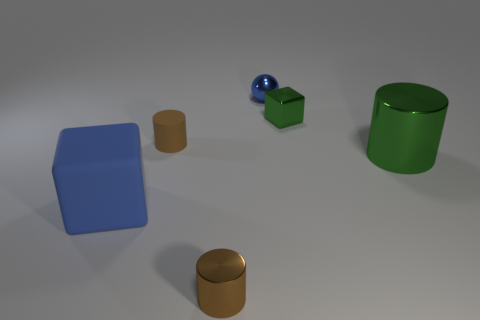There is a tiny metallic cylinder; is it the same color as the matte object to the right of the big blue matte object?
Your answer should be very brief. Yes. The metal thing that is the same color as the small rubber thing is what shape?
Give a very brief answer. Cylinder. There is a tiny matte thing; what shape is it?
Give a very brief answer. Cylinder. Do the large rubber thing and the metal ball have the same color?
Provide a short and direct response. Yes. How many objects are either cylinders to the left of the tiny blue object or small green things?
Give a very brief answer. 3. The brown cylinder that is made of the same material as the large green cylinder is what size?
Offer a very short reply. Small. Is the number of shiny blocks in front of the tiny green shiny block greater than the number of big gray cylinders?
Your answer should be very brief. No. Do the small green thing and the small object behind the tiny cube have the same shape?
Your response must be concise. No. How many small objects are matte cylinders or green cylinders?
Provide a short and direct response. 1. There is a object that is the same color as the small cube; what size is it?
Your answer should be very brief. Large. 